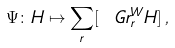Convert formula to latex. <formula><loc_0><loc_0><loc_500><loc_500>\Psi \colon H \mapsto \sum _ { r } [ \ G r _ { r } ^ { W } H ] \, ,</formula> 